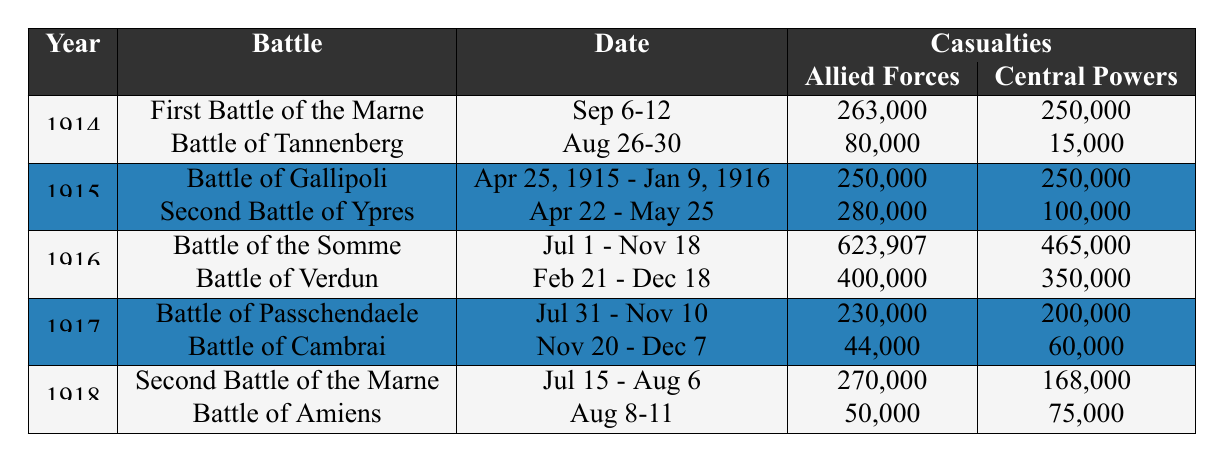What was the total number of casualties in the First Battle of the Marne? The table shows that the casualties for the First Battle of the Marne were 263,000 for Allied Forces and 250,000 for Central Powers. Adding these gives a total of 263,000 + 250,000 = 513,000 casualties.
Answer: 513,000 Which battle in 1916 had the highest number of casualties for Allied Forces? The table indicates that the Battle of the Somme had casualties of 623,907 for Allied Forces, which is higher than the Battle of Verdun's 400,000. Therefore, the Battle of the Somme had the highest casualties for Allied Forces in 1916.
Answer: Battle of the Somme Did the Central Powers suffer more casualties in the Battle of Verdun than the Battle of Cambrai? The table shows that the Central Powers had 350,000 casualties in the Battle of Verdun and 60,000 in the Battle of Cambrai. Since 350,000 is greater than 60,000, it is true that the Central Powers suffered more casualties in the Battle of Verdun.
Answer: Yes What was the total number of casualties across all battles in 1915? In 1915, the casualties were 250,000 (Gallipoli) + 250,000 (Gallipoli) + 280,000 (Second Battle of Ypres) + 100,000 (Second Battle of Ypres) = 880,000 total casualties.
Answer: 880,000 How many more casualties did the Allied Forces suffer in the Battle of the Somme compared to the Battle of Passchendaele? The battle casualties for the Allied Forces were 623,907 in the Battle of the Somme and 230,000 in the Battle of Passchendaele. The difference is 623,907 - 230,000 = 393,907.
Answer: 393,907 What was the average number of casualties for the Central Powers in 1918 battles? In 1918, the Central Powers suffered 168,000 in the Second Battle of the Marne and 75,000 in the Battle of Amiens. The total casualties for Central Powers in these battles is 168,000 + 75,000 = 243,000. To find the average, we divide by the number of battles (2): 243,000 / 2 = 121,500.
Answer: 121,500 Which year had the most battles listed in the table? The table indicates that 1914, 1915, 1916, 1917, and 1918 each list two battles. Since they all have the same amount, there is no single year with the most battles; they are all equal.
Answer: No specific year What is the total number of casualties for the allies in the Battles of Amiens and Gallipoli? From the table, the casualties for Allied Forces in the Battle of Amiens are 50,000 and in the Battle of Gallipoli are 250,000. Therefore, the total is 50,000 + 250,000 = 300,000 for Allied Forces.
Answer: 300,000 How did the casualties of Central Powers in the Battle of Tannenberg compare to the Second Battle of the Marne? According to the table, Central Powers had 15,000 casualties in the Battle of Tannenberg and 168,000 in the Second Battle of the Marne. Since 15,000 is significantly less than 168,000, it shows that casualties in the Second Battle of the Marne were much higher.
Answer: Second Battle of the Marne had higher casualties 